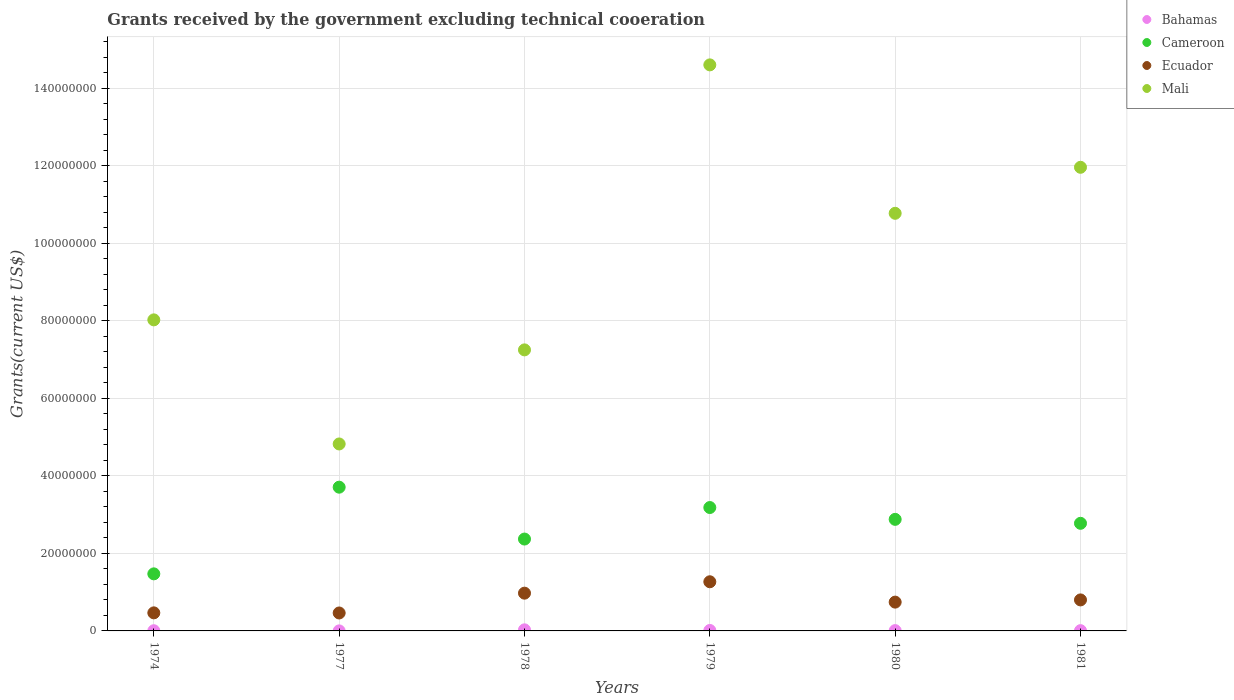How many different coloured dotlines are there?
Offer a terse response. 4. What is the total grants received by the government in Bahamas in 1979?
Provide a succinct answer. 1.20e+05. Across all years, what is the maximum total grants received by the government in Bahamas?
Provide a succinct answer. 2.80e+05. Across all years, what is the minimum total grants received by the government in Cameroon?
Provide a succinct answer. 1.47e+07. In which year was the total grants received by the government in Bahamas maximum?
Offer a terse response. 1978. In which year was the total grants received by the government in Cameroon minimum?
Your answer should be very brief. 1974. What is the total total grants received by the government in Cameroon in the graph?
Provide a succinct answer. 1.64e+08. What is the difference between the total grants received by the government in Bahamas in 1974 and that in 1981?
Provide a short and direct response. -2.00e+04. What is the difference between the total grants received by the government in Ecuador in 1980 and the total grants received by the government in Mali in 1977?
Your response must be concise. -4.08e+07. What is the average total grants received by the government in Mali per year?
Keep it short and to the point. 9.57e+07. In the year 1980, what is the difference between the total grants received by the government in Bahamas and total grants received by the government in Ecuador?
Give a very brief answer. -7.35e+06. What is the ratio of the total grants received by the government in Mali in 1977 to that in 1978?
Give a very brief answer. 0.67. Is the total grants received by the government in Ecuador in 1974 less than that in 1977?
Your response must be concise. No. What is the difference between the highest and the second highest total grants received by the government in Cameroon?
Your answer should be compact. 5.25e+06. What is the difference between the highest and the lowest total grants received by the government in Bahamas?
Your answer should be compact. 2.70e+05. In how many years, is the total grants received by the government in Cameroon greater than the average total grants received by the government in Cameroon taken over all years?
Keep it short and to the point. 4. Is the sum of the total grants received by the government in Ecuador in 1974 and 1977 greater than the maximum total grants received by the government in Mali across all years?
Give a very brief answer. No. Is it the case that in every year, the sum of the total grants received by the government in Cameroon and total grants received by the government in Mali  is greater than the total grants received by the government in Ecuador?
Keep it short and to the point. Yes. Is the total grants received by the government in Bahamas strictly less than the total grants received by the government in Ecuador over the years?
Your answer should be very brief. Yes. How many dotlines are there?
Offer a very short reply. 4. What is the difference between two consecutive major ticks on the Y-axis?
Your response must be concise. 2.00e+07. Does the graph contain any zero values?
Give a very brief answer. No. Where does the legend appear in the graph?
Ensure brevity in your answer.  Top right. How many legend labels are there?
Ensure brevity in your answer.  4. What is the title of the graph?
Provide a short and direct response. Grants received by the government excluding technical cooeration. Does "Caribbean small states" appear as one of the legend labels in the graph?
Offer a very short reply. No. What is the label or title of the X-axis?
Your answer should be very brief. Years. What is the label or title of the Y-axis?
Your answer should be compact. Grants(current US$). What is the Grants(current US$) of Cameroon in 1974?
Ensure brevity in your answer.  1.47e+07. What is the Grants(current US$) in Ecuador in 1974?
Make the answer very short. 4.66e+06. What is the Grants(current US$) in Mali in 1974?
Your answer should be very brief. 8.02e+07. What is the Grants(current US$) in Bahamas in 1977?
Your response must be concise. 10000. What is the Grants(current US$) of Cameroon in 1977?
Provide a short and direct response. 3.71e+07. What is the Grants(current US$) in Ecuador in 1977?
Offer a terse response. 4.63e+06. What is the Grants(current US$) in Mali in 1977?
Offer a very short reply. 4.82e+07. What is the Grants(current US$) in Cameroon in 1978?
Give a very brief answer. 2.37e+07. What is the Grants(current US$) in Ecuador in 1978?
Keep it short and to the point. 9.74e+06. What is the Grants(current US$) of Mali in 1978?
Provide a succinct answer. 7.25e+07. What is the Grants(current US$) in Bahamas in 1979?
Your response must be concise. 1.20e+05. What is the Grants(current US$) of Cameroon in 1979?
Ensure brevity in your answer.  3.18e+07. What is the Grants(current US$) in Ecuador in 1979?
Ensure brevity in your answer.  1.27e+07. What is the Grants(current US$) in Mali in 1979?
Keep it short and to the point. 1.46e+08. What is the Grants(current US$) of Bahamas in 1980?
Your answer should be compact. 8.00e+04. What is the Grants(current US$) in Cameroon in 1980?
Make the answer very short. 2.88e+07. What is the Grants(current US$) of Ecuador in 1980?
Your answer should be very brief. 7.43e+06. What is the Grants(current US$) in Mali in 1980?
Keep it short and to the point. 1.08e+08. What is the Grants(current US$) in Bahamas in 1981?
Your answer should be compact. 7.00e+04. What is the Grants(current US$) of Cameroon in 1981?
Keep it short and to the point. 2.78e+07. What is the Grants(current US$) in Mali in 1981?
Ensure brevity in your answer.  1.20e+08. Across all years, what is the maximum Grants(current US$) in Cameroon?
Ensure brevity in your answer.  3.71e+07. Across all years, what is the maximum Grants(current US$) in Ecuador?
Make the answer very short. 1.27e+07. Across all years, what is the maximum Grants(current US$) in Mali?
Make the answer very short. 1.46e+08. Across all years, what is the minimum Grants(current US$) in Bahamas?
Your answer should be very brief. 10000. Across all years, what is the minimum Grants(current US$) of Cameroon?
Offer a terse response. 1.47e+07. Across all years, what is the minimum Grants(current US$) in Ecuador?
Make the answer very short. 4.63e+06. Across all years, what is the minimum Grants(current US$) of Mali?
Give a very brief answer. 4.82e+07. What is the total Grants(current US$) in Cameroon in the graph?
Provide a short and direct response. 1.64e+08. What is the total Grants(current US$) of Ecuador in the graph?
Your response must be concise. 4.71e+07. What is the total Grants(current US$) of Mali in the graph?
Provide a succinct answer. 5.74e+08. What is the difference between the Grants(current US$) in Cameroon in 1974 and that in 1977?
Offer a very short reply. -2.24e+07. What is the difference between the Grants(current US$) of Mali in 1974 and that in 1977?
Provide a short and direct response. 3.20e+07. What is the difference between the Grants(current US$) in Cameroon in 1974 and that in 1978?
Provide a short and direct response. -8.98e+06. What is the difference between the Grants(current US$) of Ecuador in 1974 and that in 1978?
Make the answer very short. -5.08e+06. What is the difference between the Grants(current US$) of Mali in 1974 and that in 1978?
Offer a very short reply. 7.74e+06. What is the difference between the Grants(current US$) of Cameroon in 1974 and that in 1979?
Make the answer very short. -1.71e+07. What is the difference between the Grants(current US$) in Ecuador in 1974 and that in 1979?
Your answer should be very brief. -8.02e+06. What is the difference between the Grants(current US$) in Mali in 1974 and that in 1979?
Provide a short and direct response. -6.58e+07. What is the difference between the Grants(current US$) in Bahamas in 1974 and that in 1980?
Make the answer very short. -3.00e+04. What is the difference between the Grants(current US$) of Cameroon in 1974 and that in 1980?
Offer a terse response. -1.41e+07. What is the difference between the Grants(current US$) of Ecuador in 1974 and that in 1980?
Ensure brevity in your answer.  -2.77e+06. What is the difference between the Grants(current US$) in Mali in 1974 and that in 1980?
Your response must be concise. -2.75e+07. What is the difference between the Grants(current US$) in Bahamas in 1974 and that in 1981?
Offer a very short reply. -2.00e+04. What is the difference between the Grants(current US$) in Cameroon in 1974 and that in 1981?
Offer a very short reply. -1.30e+07. What is the difference between the Grants(current US$) in Ecuador in 1974 and that in 1981?
Offer a terse response. -3.34e+06. What is the difference between the Grants(current US$) in Mali in 1974 and that in 1981?
Offer a terse response. -3.94e+07. What is the difference between the Grants(current US$) of Bahamas in 1977 and that in 1978?
Give a very brief answer. -2.70e+05. What is the difference between the Grants(current US$) in Cameroon in 1977 and that in 1978?
Offer a very short reply. 1.34e+07. What is the difference between the Grants(current US$) of Ecuador in 1977 and that in 1978?
Make the answer very short. -5.11e+06. What is the difference between the Grants(current US$) of Mali in 1977 and that in 1978?
Give a very brief answer. -2.43e+07. What is the difference between the Grants(current US$) of Bahamas in 1977 and that in 1979?
Provide a succinct answer. -1.10e+05. What is the difference between the Grants(current US$) of Cameroon in 1977 and that in 1979?
Your answer should be very brief. 5.25e+06. What is the difference between the Grants(current US$) of Ecuador in 1977 and that in 1979?
Provide a short and direct response. -8.05e+06. What is the difference between the Grants(current US$) in Mali in 1977 and that in 1979?
Ensure brevity in your answer.  -9.78e+07. What is the difference between the Grants(current US$) in Cameroon in 1977 and that in 1980?
Your answer should be compact. 8.30e+06. What is the difference between the Grants(current US$) in Ecuador in 1977 and that in 1980?
Offer a terse response. -2.80e+06. What is the difference between the Grants(current US$) in Mali in 1977 and that in 1980?
Keep it short and to the point. -5.95e+07. What is the difference between the Grants(current US$) in Cameroon in 1977 and that in 1981?
Provide a succinct answer. 9.32e+06. What is the difference between the Grants(current US$) in Ecuador in 1977 and that in 1981?
Provide a short and direct response. -3.37e+06. What is the difference between the Grants(current US$) of Mali in 1977 and that in 1981?
Your response must be concise. -7.14e+07. What is the difference between the Grants(current US$) in Bahamas in 1978 and that in 1979?
Your response must be concise. 1.60e+05. What is the difference between the Grants(current US$) in Cameroon in 1978 and that in 1979?
Keep it short and to the point. -8.13e+06. What is the difference between the Grants(current US$) of Ecuador in 1978 and that in 1979?
Give a very brief answer. -2.94e+06. What is the difference between the Grants(current US$) in Mali in 1978 and that in 1979?
Provide a succinct answer. -7.35e+07. What is the difference between the Grants(current US$) of Bahamas in 1978 and that in 1980?
Offer a very short reply. 2.00e+05. What is the difference between the Grants(current US$) in Cameroon in 1978 and that in 1980?
Offer a very short reply. -5.08e+06. What is the difference between the Grants(current US$) in Ecuador in 1978 and that in 1980?
Make the answer very short. 2.31e+06. What is the difference between the Grants(current US$) of Mali in 1978 and that in 1980?
Offer a terse response. -3.52e+07. What is the difference between the Grants(current US$) of Bahamas in 1978 and that in 1981?
Your answer should be compact. 2.10e+05. What is the difference between the Grants(current US$) of Cameroon in 1978 and that in 1981?
Provide a succinct answer. -4.06e+06. What is the difference between the Grants(current US$) of Ecuador in 1978 and that in 1981?
Keep it short and to the point. 1.74e+06. What is the difference between the Grants(current US$) in Mali in 1978 and that in 1981?
Your answer should be compact. -4.71e+07. What is the difference between the Grants(current US$) in Bahamas in 1979 and that in 1980?
Your answer should be very brief. 4.00e+04. What is the difference between the Grants(current US$) in Cameroon in 1979 and that in 1980?
Your answer should be compact. 3.05e+06. What is the difference between the Grants(current US$) of Ecuador in 1979 and that in 1980?
Your answer should be very brief. 5.25e+06. What is the difference between the Grants(current US$) in Mali in 1979 and that in 1980?
Ensure brevity in your answer.  3.83e+07. What is the difference between the Grants(current US$) in Bahamas in 1979 and that in 1981?
Offer a very short reply. 5.00e+04. What is the difference between the Grants(current US$) of Cameroon in 1979 and that in 1981?
Keep it short and to the point. 4.07e+06. What is the difference between the Grants(current US$) in Ecuador in 1979 and that in 1981?
Keep it short and to the point. 4.68e+06. What is the difference between the Grants(current US$) in Mali in 1979 and that in 1981?
Give a very brief answer. 2.64e+07. What is the difference between the Grants(current US$) of Bahamas in 1980 and that in 1981?
Provide a succinct answer. 10000. What is the difference between the Grants(current US$) of Cameroon in 1980 and that in 1981?
Offer a very short reply. 1.02e+06. What is the difference between the Grants(current US$) of Ecuador in 1980 and that in 1981?
Your response must be concise. -5.70e+05. What is the difference between the Grants(current US$) in Mali in 1980 and that in 1981?
Your response must be concise. -1.19e+07. What is the difference between the Grants(current US$) in Bahamas in 1974 and the Grants(current US$) in Cameroon in 1977?
Give a very brief answer. -3.70e+07. What is the difference between the Grants(current US$) in Bahamas in 1974 and the Grants(current US$) in Ecuador in 1977?
Ensure brevity in your answer.  -4.58e+06. What is the difference between the Grants(current US$) of Bahamas in 1974 and the Grants(current US$) of Mali in 1977?
Your answer should be very brief. -4.82e+07. What is the difference between the Grants(current US$) of Cameroon in 1974 and the Grants(current US$) of Ecuador in 1977?
Your answer should be compact. 1.01e+07. What is the difference between the Grants(current US$) in Cameroon in 1974 and the Grants(current US$) in Mali in 1977?
Your answer should be compact. -3.35e+07. What is the difference between the Grants(current US$) in Ecuador in 1974 and the Grants(current US$) in Mali in 1977?
Your answer should be very brief. -4.36e+07. What is the difference between the Grants(current US$) of Bahamas in 1974 and the Grants(current US$) of Cameroon in 1978?
Provide a succinct answer. -2.36e+07. What is the difference between the Grants(current US$) in Bahamas in 1974 and the Grants(current US$) in Ecuador in 1978?
Your answer should be very brief. -9.69e+06. What is the difference between the Grants(current US$) in Bahamas in 1974 and the Grants(current US$) in Mali in 1978?
Keep it short and to the point. -7.24e+07. What is the difference between the Grants(current US$) in Cameroon in 1974 and the Grants(current US$) in Ecuador in 1978?
Your response must be concise. 4.98e+06. What is the difference between the Grants(current US$) of Cameroon in 1974 and the Grants(current US$) of Mali in 1978?
Offer a terse response. -5.78e+07. What is the difference between the Grants(current US$) in Ecuador in 1974 and the Grants(current US$) in Mali in 1978?
Your answer should be very brief. -6.78e+07. What is the difference between the Grants(current US$) in Bahamas in 1974 and the Grants(current US$) in Cameroon in 1979?
Keep it short and to the point. -3.18e+07. What is the difference between the Grants(current US$) in Bahamas in 1974 and the Grants(current US$) in Ecuador in 1979?
Keep it short and to the point. -1.26e+07. What is the difference between the Grants(current US$) in Bahamas in 1974 and the Grants(current US$) in Mali in 1979?
Provide a succinct answer. -1.46e+08. What is the difference between the Grants(current US$) in Cameroon in 1974 and the Grants(current US$) in Ecuador in 1979?
Provide a succinct answer. 2.04e+06. What is the difference between the Grants(current US$) of Cameroon in 1974 and the Grants(current US$) of Mali in 1979?
Keep it short and to the point. -1.31e+08. What is the difference between the Grants(current US$) in Ecuador in 1974 and the Grants(current US$) in Mali in 1979?
Give a very brief answer. -1.41e+08. What is the difference between the Grants(current US$) in Bahamas in 1974 and the Grants(current US$) in Cameroon in 1980?
Offer a very short reply. -2.87e+07. What is the difference between the Grants(current US$) in Bahamas in 1974 and the Grants(current US$) in Ecuador in 1980?
Keep it short and to the point. -7.38e+06. What is the difference between the Grants(current US$) in Bahamas in 1974 and the Grants(current US$) in Mali in 1980?
Ensure brevity in your answer.  -1.08e+08. What is the difference between the Grants(current US$) of Cameroon in 1974 and the Grants(current US$) of Ecuador in 1980?
Provide a succinct answer. 7.29e+06. What is the difference between the Grants(current US$) in Cameroon in 1974 and the Grants(current US$) in Mali in 1980?
Your response must be concise. -9.30e+07. What is the difference between the Grants(current US$) in Ecuador in 1974 and the Grants(current US$) in Mali in 1980?
Offer a very short reply. -1.03e+08. What is the difference between the Grants(current US$) in Bahamas in 1974 and the Grants(current US$) in Cameroon in 1981?
Keep it short and to the point. -2.77e+07. What is the difference between the Grants(current US$) in Bahamas in 1974 and the Grants(current US$) in Ecuador in 1981?
Your response must be concise. -7.95e+06. What is the difference between the Grants(current US$) of Bahamas in 1974 and the Grants(current US$) of Mali in 1981?
Offer a terse response. -1.20e+08. What is the difference between the Grants(current US$) of Cameroon in 1974 and the Grants(current US$) of Ecuador in 1981?
Provide a short and direct response. 6.72e+06. What is the difference between the Grants(current US$) of Cameroon in 1974 and the Grants(current US$) of Mali in 1981?
Provide a short and direct response. -1.05e+08. What is the difference between the Grants(current US$) in Ecuador in 1974 and the Grants(current US$) in Mali in 1981?
Offer a terse response. -1.15e+08. What is the difference between the Grants(current US$) in Bahamas in 1977 and the Grants(current US$) in Cameroon in 1978?
Your answer should be compact. -2.37e+07. What is the difference between the Grants(current US$) of Bahamas in 1977 and the Grants(current US$) of Ecuador in 1978?
Your response must be concise. -9.73e+06. What is the difference between the Grants(current US$) of Bahamas in 1977 and the Grants(current US$) of Mali in 1978?
Give a very brief answer. -7.25e+07. What is the difference between the Grants(current US$) of Cameroon in 1977 and the Grants(current US$) of Ecuador in 1978?
Make the answer very short. 2.73e+07. What is the difference between the Grants(current US$) in Cameroon in 1977 and the Grants(current US$) in Mali in 1978?
Your answer should be very brief. -3.54e+07. What is the difference between the Grants(current US$) in Ecuador in 1977 and the Grants(current US$) in Mali in 1978?
Give a very brief answer. -6.79e+07. What is the difference between the Grants(current US$) in Bahamas in 1977 and the Grants(current US$) in Cameroon in 1979?
Offer a very short reply. -3.18e+07. What is the difference between the Grants(current US$) in Bahamas in 1977 and the Grants(current US$) in Ecuador in 1979?
Your answer should be compact. -1.27e+07. What is the difference between the Grants(current US$) of Bahamas in 1977 and the Grants(current US$) of Mali in 1979?
Provide a succinct answer. -1.46e+08. What is the difference between the Grants(current US$) in Cameroon in 1977 and the Grants(current US$) in Ecuador in 1979?
Provide a succinct answer. 2.44e+07. What is the difference between the Grants(current US$) in Cameroon in 1977 and the Grants(current US$) in Mali in 1979?
Make the answer very short. -1.09e+08. What is the difference between the Grants(current US$) of Ecuador in 1977 and the Grants(current US$) of Mali in 1979?
Provide a succinct answer. -1.41e+08. What is the difference between the Grants(current US$) in Bahamas in 1977 and the Grants(current US$) in Cameroon in 1980?
Ensure brevity in your answer.  -2.88e+07. What is the difference between the Grants(current US$) of Bahamas in 1977 and the Grants(current US$) of Ecuador in 1980?
Provide a short and direct response. -7.42e+06. What is the difference between the Grants(current US$) of Bahamas in 1977 and the Grants(current US$) of Mali in 1980?
Your response must be concise. -1.08e+08. What is the difference between the Grants(current US$) of Cameroon in 1977 and the Grants(current US$) of Ecuador in 1980?
Offer a terse response. 2.96e+07. What is the difference between the Grants(current US$) of Cameroon in 1977 and the Grants(current US$) of Mali in 1980?
Make the answer very short. -7.06e+07. What is the difference between the Grants(current US$) of Ecuador in 1977 and the Grants(current US$) of Mali in 1980?
Your answer should be very brief. -1.03e+08. What is the difference between the Grants(current US$) in Bahamas in 1977 and the Grants(current US$) in Cameroon in 1981?
Your response must be concise. -2.78e+07. What is the difference between the Grants(current US$) of Bahamas in 1977 and the Grants(current US$) of Ecuador in 1981?
Give a very brief answer. -7.99e+06. What is the difference between the Grants(current US$) of Bahamas in 1977 and the Grants(current US$) of Mali in 1981?
Your response must be concise. -1.20e+08. What is the difference between the Grants(current US$) of Cameroon in 1977 and the Grants(current US$) of Ecuador in 1981?
Offer a terse response. 2.91e+07. What is the difference between the Grants(current US$) in Cameroon in 1977 and the Grants(current US$) in Mali in 1981?
Make the answer very short. -8.25e+07. What is the difference between the Grants(current US$) of Ecuador in 1977 and the Grants(current US$) of Mali in 1981?
Your answer should be very brief. -1.15e+08. What is the difference between the Grants(current US$) of Bahamas in 1978 and the Grants(current US$) of Cameroon in 1979?
Ensure brevity in your answer.  -3.16e+07. What is the difference between the Grants(current US$) of Bahamas in 1978 and the Grants(current US$) of Ecuador in 1979?
Provide a short and direct response. -1.24e+07. What is the difference between the Grants(current US$) of Bahamas in 1978 and the Grants(current US$) of Mali in 1979?
Give a very brief answer. -1.46e+08. What is the difference between the Grants(current US$) of Cameroon in 1978 and the Grants(current US$) of Ecuador in 1979?
Your answer should be compact. 1.10e+07. What is the difference between the Grants(current US$) in Cameroon in 1978 and the Grants(current US$) in Mali in 1979?
Your answer should be very brief. -1.22e+08. What is the difference between the Grants(current US$) in Ecuador in 1978 and the Grants(current US$) in Mali in 1979?
Your answer should be very brief. -1.36e+08. What is the difference between the Grants(current US$) of Bahamas in 1978 and the Grants(current US$) of Cameroon in 1980?
Offer a terse response. -2.85e+07. What is the difference between the Grants(current US$) of Bahamas in 1978 and the Grants(current US$) of Ecuador in 1980?
Ensure brevity in your answer.  -7.15e+06. What is the difference between the Grants(current US$) in Bahamas in 1978 and the Grants(current US$) in Mali in 1980?
Make the answer very short. -1.07e+08. What is the difference between the Grants(current US$) of Cameroon in 1978 and the Grants(current US$) of Ecuador in 1980?
Make the answer very short. 1.63e+07. What is the difference between the Grants(current US$) of Cameroon in 1978 and the Grants(current US$) of Mali in 1980?
Provide a short and direct response. -8.40e+07. What is the difference between the Grants(current US$) of Ecuador in 1978 and the Grants(current US$) of Mali in 1980?
Provide a short and direct response. -9.80e+07. What is the difference between the Grants(current US$) of Bahamas in 1978 and the Grants(current US$) of Cameroon in 1981?
Offer a terse response. -2.75e+07. What is the difference between the Grants(current US$) of Bahamas in 1978 and the Grants(current US$) of Ecuador in 1981?
Give a very brief answer. -7.72e+06. What is the difference between the Grants(current US$) in Bahamas in 1978 and the Grants(current US$) in Mali in 1981?
Offer a terse response. -1.19e+08. What is the difference between the Grants(current US$) of Cameroon in 1978 and the Grants(current US$) of Ecuador in 1981?
Offer a terse response. 1.57e+07. What is the difference between the Grants(current US$) in Cameroon in 1978 and the Grants(current US$) in Mali in 1981?
Give a very brief answer. -9.59e+07. What is the difference between the Grants(current US$) in Ecuador in 1978 and the Grants(current US$) in Mali in 1981?
Your response must be concise. -1.10e+08. What is the difference between the Grants(current US$) of Bahamas in 1979 and the Grants(current US$) of Cameroon in 1980?
Offer a terse response. -2.87e+07. What is the difference between the Grants(current US$) of Bahamas in 1979 and the Grants(current US$) of Ecuador in 1980?
Your answer should be very brief. -7.31e+06. What is the difference between the Grants(current US$) of Bahamas in 1979 and the Grants(current US$) of Mali in 1980?
Ensure brevity in your answer.  -1.08e+08. What is the difference between the Grants(current US$) in Cameroon in 1979 and the Grants(current US$) in Ecuador in 1980?
Keep it short and to the point. 2.44e+07. What is the difference between the Grants(current US$) in Cameroon in 1979 and the Grants(current US$) in Mali in 1980?
Provide a short and direct response. -7.59e+07. What is the difference between the Grants(current US$) in Ecuador in 1979 and the Grants(current US$) in Mali in 1980?
Make the answer very short. -9.50e+07. What is the difference between the Grants(current US$) in Bahamas in 1979 and the Grants(current US$) in Cameroon in 1981?
Ensure brevity in your answer.  -2.76e+07. What is the difference between the Grants(current US$) in Bahamas in 1979 and the Grants(current US$) in Ecuador in 1981?
Provide a succinct answer. -7.88e+06. What is the difference between the Grants(current US$) of Bahamas in 1979 and the Grants(current US$) of Mali in 1981?
Your answer should be compact. -1.19e+08. What is the difference between the Grants(current US$) of Cameroon in 1979 and the Grants(current US$) of Ecuador in 1981?
Your response must be concise. 2.38e+07. What is the difference between the Grants(current US$) of Cameroon in 1979 and the Grants(current US$) of Mali in 1981?
Your answer should be very brief. -8.78e+07. What is the difference between the Grants(current US$) in Ecuador in 1979 and the Grants(current US$) in Mali in 1981?
Your response must be concise. -1.07e+08. What is the difference between the Grants(current US$) in Bahamas in 1980 and the Grants(current US$) in Cameroon in 1981?
Ensure brevity in your answer.  -2.77e+07. What is the difference between the Grants(current US$) of Bahamas in 1980 and the Grants(current US$) of Ecuador in 1981?
Offer a terse response. -7.92e+06. What is the difference between the Grants(current US$) in Bahamas in 1980 and the Grants(current US$) in Mali in 1981?
Give a very brief answer. -1.20e+08. What is the difference between the Grants(current US$) of Cameroon in 1980 and the Grants(current US$) of Ecuador in 1981?
Give a very brief answer. 2.08e+07. What is the difference between the Grants(current US$) of Cameroon in 1980 and the Grants(current US$) of Mali in 1981?
Ensure brevity in your answer.  -9.08e+07. What is the difference between the Grants(current US$) of Ecuador in 1980 and the Grants(current US$) of Mali in 1981?
Your response must be concise. -1.12e+08. What is the average Grants(current US$) of Bahamas per year?
Make the answer very short. 1.02e+05. What is the average Grants(current US$) of Cameroon per year?
Offer a very short reply. 2.73e+07. What is the average Grants(current US$) in Ecuador per year?
Provide a succinct answer. 7.86e+06. What is the average Grants(current US$) of Mali per year?
Ensure brevity in your answer.  9.57e+07. In the year 1974, what is the difference between the Grants(current US$) of Bahamas and Grants(current US$) of Cameroon?
Provide a succinct answer. -1.47e+07. In the year 1974, what is the difference between the Grants(current US$) of Bahamas and Grants(current US$) of Ecuador?
Your answer should be compact. -4.61e+06. In the year 1974, what is the difference between the Grants(current US$) of Bahamas and Grants(current US$) of Mali?
Ensure brevity in your answer.  -8.02e+07. In the year 1974, what is the difference between the Grants(current US$) of Cameroon and Grants(current US$) of Ecuador?
Offer a very short reply. 1.01e+07. In the year 1974, what is the difference between the Grants(current US$) in Cameroon and Grants(current US$) in Mali?
Offer a terse response. -6.55e+07. In the year 1974, what is the difference between the Grants(current US$) of Ecuador and Grants(current US$) of Mali?
Your response must be concise. -7.56e+07. In the year 1977, what is the difference between the Grants(current US$) in Bahamas and Grants(current US$) in Cameroon?
Your answer should be very brief. -3.71e+07. In the year 1977, what is the difference between the Grants(current US$) in Bahamas and Grants(current US$) in Ecuador?
Your answer should be very brief. -4.62e+06. In the year 1977, what is the difference between the Grants(current US$) of Bahamas and Grants(current US$) of Mali?
Your answer should be compact. -4.82e+07. In the year 1977, what is the difference between the Grants(current US$) of Cameroon and Grants(current US$) of Ecuador?
Provide a short and direct response. 3.24e+07. In the year 1977, what is the difference between the Grants(current US$) in Cameroon and Grants(current US$) in Mali?
Your answer should be compact. -1.12e+07. In the year 1977, what is the difference between the Grants(current US$) of Ecuador and Grants(current US$) of Mali?
Keep it short and to the point. -4.36e+07. In the year 1978, what is the difference between the Grants(current US$) of Bahamas and Grants(current US$) of Cameroon?
Your response must be concise. -2.34e+07. In the year 1978, what is the difference between the Grants(current US$) of Bahamas and Grants(current US$) of Ecuador?
Your answer should be very brief. -9.46e+06. In the year 1978, what is the difference between the Grants(current US$) of Bahamas and Grants(current US$) of Mali?
Offer a terse response. -7.22e+07. In the year 1978, what is the difference between the Grants(current US$) of Cameroon and Grants(current US$) of Ecuador?
Offer a terse response. 1.40e+07. In the year 1978, what is the difference between the Grants(current US$) in Cameroon and Grants(current US$) in Mali?
Your answer should be very brief. -4.88e+07. In the year 1978, what is the difference between the Grants(current US$) in Ecuador and Grants(current US$) in Mali?
Provide a succinct answer. -6.28e+07. In the year 1979, what is the difference between the Grants(current US$) in Bahamas and Grants(current US$) in Cameroon?
Give a very brief answer. -3.17e+07. In the year 1979, what is the difference between the Grants(current US$) in Bahamas and Grants(current US$) in Ecuador?
Your answer should be very brief. -1.26e+07. In the year 1979, what is the difference between the Grants(current US$) of Bahamas and Grants(current US$) of Mali?
Offer a very short reply. -1.46e+08. In the year 1979, what is the difference between the Grants(current US$) of Cameroon and Grants(current US$) of Ecuador?
Your answer should be compact. 1.92e+07. In the year 1979, what is the difference between the Grants(current US$) in Cameroon and Grants(current US$) in Mali?
Your answer should be compact. -1.14e+08. In the year 1979, what is the difference between the Grants(current US$) in Ecuador and Grants(current US$) in Mali?
Provide a short and direct response. -1.33e+08. In the year 1980, what is the difference between the Grants(current US$) of Bahamas and Grants(current US$) of Cameroon?
Your answer should be very brief. -2.87e+07. In the year 1980, what is the difference between the Grants(current US$) in Bahamas and Grants(current US$) in Ecuador?
Provide a short and direct response. -7.35e+06. In the year 1980, what is the difference between the Grants(current US$) in Bahamas and Grants(current US$) in Mali?
Make the answer very short. -1.08e+08. In the year 1980, what is the difference between the Grants(current US$) of Cameroon and Grants(current US$) of Ecuador?
Keep it short and to the point. 2.14e+07. In the year 1980, what is the difference between the Grants(current US$) in Cameroon and Grants(current US$) in Mali?
Offer a terse response. -7.90e+07. In the year 1980, what is the difference between the Grants(current US$) of Ecuador and Grants(current US$) of Mali?
Your answer should be very brief. -1.00e+08. In the year 1981, what is the difference between the Grants(current US$) in Bahamas and Grants(current US$) in Cameroon?
Offer a terse response. -2.77e+07. In the year 1981, what is the difference between the Grants(current US$) in Bahamas and Grants(current US$) in Ecuador?
Ensure brevity in your answer.  -7.93e+06. In the year 1981, what is the difference between the Grants(current US$) in Bahamas and Grants(current US$) in Mali?
Provide a succinct answer. -1.20e+08. In the year 1981, what is the difference between the Grants(current US$) in Cameroon and Grants(current US$) in Ecuador?
Give a very brief answer. 1.98e+07. In the year 1981, what is the difference between the Grants(current US$) in Cameroon and Grants(current US$) in Mali?
Keep it short and to the point. -9.18e+07. In the year 1981, what is the difference between the Grants(current US$) of Ecuador and Grants(current US$) of Mali?
Give a very brief answer. -1.12e+08. What is the ratio of the Grants(current US$) of Cameroon in 1974 to that in 1977?
Offer a very short reply. 0.4. What is the ratio of the Grants(current US$) of Mali in 1974 to that in 1977?
Ensure brevity in your answer.  1.66. What is the ratio of the Grants(current US$) in Bahamas in 1974 to that in 1978?
Give a very brief answer. 0.18. What is the ratio of the Grants(current US$) of Cameroon in 1974 to that in 1978?
Provide a succinct answer. 0.62. What is the ratio of the Grants(current US$) of Ecuador in 1974 to that in 1978?
Your response must be concise. 0.48. What is the ratio of the Grants(current US$) in Mali in 1974 to that in 1978?
Ensure brevity in your answer.  1.11. What is the ratio of the Grants(current US$) in Bahamas in 1974 to that in 1979?
Ensure brevity in your answer.  0.42. What is the ratio of the Grants(current US$) of Cameroon in 1974 to that in 1979?
Your answer should be very brief. 0.46. What is the ratio of the Grants(current US$) of Ecuador in 1974 to that in 1979?
Give a very brief answer. 0.37. What is the ratio of the Grants(current US$) in Mali in 1974 to that in 1979?
Your answer should be very brief. 0.55. What is the ratio of the Grants(current US$) in Bahamas in 1974 to that in 1980?
Your response must be concise. 0.62. What is the ratio of the Grants(current US$) in Cameroon in 1974 to that in 1980?
Your answer should be compact. 0.51. What is the ratio of the Grants(current US$) of Ecuador in 1974 to that in 1980?
Offer a terse response. 0.63. What is the ratio of the Grants(current US$) of Mali in 1974 to that in 1980?
Give a very brief answer. 0.74. What is the ratio of the Grants(current US$) of Bahamas in 1974 to that in 1981?
Your answer should be very brief. 0.71. What is the ratio of the Grants(current US$) in Cameroon in 1974 to that in 1981?
Provide a short and direct response. 0.53. What is the ratio of the Grants(current US$) in Ecuador in 1974 to that in 1981?
Your response must be concise. 0.58. What is the ratio of the Grants(current US$) in Mali in 1974 to that in 1981?
Provide a succinct answer. 0.67. What is the ratio of the Grants(current US$) of Bahamas in 1977 to that in 1978?
Your answer should be compact. 0.04. What is the ratio of the Grants(current US$) in Cameroon in 1977 to that in 1978?
Offer a terse response. 1.56. What is the ratio of the Grants(current US$) of Ecuador in 1977 to that in 1978?
Provide a short and direct response. 0.48. What is the ratio of the Grants(current US$) in Mali in 1977 to that in 1978?
Ensure brevity in your answer.  0.67. What is the ratio of the Grants(current US$) of Bahamas in 1977 to that in 1979?
Provide a short and direct response. 0.08. What is the ratio of the Grants(current US$) in Cameroon in 1977 to that in 1979?
Provide a succinct answer. 1.16. What is the ratio of the Grants(current US$) in Ecuador in 1977 to that in 1979?
Ensure brevity in your answer.  0.37. What is the ratio of the Grants(current US$) of Mali in 1977 to that in 1979?
Provide a short and direct response. 0.33. What is the ratio of the Grants(current US$) of Bahamas in 1977 to that in 1980?
Your response must be concise. 0.12. What is the ratio of the Grants(current US$) of Cameroon in 1977 to that in 1980?
Give a very brief answer. 1.29. What is the ratio of the Grants(current US$) of Ecuador in 1977 to that in 1980?
Offer a terse response. 0.62. What is the ratio of the Grants(current US$) of Mali in 1977 to that in 1980?
Keep it short and to the point. 0.45. What is the ratio of the Grants(current US$) of Bahamas in 1977 to that in 1981?
Give a very brief answer. 0.14. What is the ratio of the Grants(current US$) in Cameroon in 1977 to that in 1981?
Make the answer very short. 1.34. What is the ratio of the Grants(current US$) in Ecuador in 1977 to that in 1981?
Make the answer very short. 0.58. What is the ratio of the Grants(current US$) in Mali in 1977 to that in 1981?
Provide a short and direct response. 0.4. What is the ratio of the Grants(current US$) of Bahamas in 1978 to that in 1979?
Offer a very short reply. 2.33. What is the ratio of the Grants(current US$) in Cameroon in 1978 to that in 1979?
Keep it short and to the point. 0.74. What is the ratio of the Grants(current US$) in Ecuador in 1978 to that in 1979?
Your response must be concise. 0.77. What is the ratio of the Grants(current US$) of Mali in 1978 to that in 1979?
Provide a short and direct response. 0.5. What is the ratio of the Grants(current US$) of Bahamas in 1978 to that in 1980?
Ensure brevity in your answer.  3.5. What is the ratio of the Grants(current US$) in Cameroon in 1978 to that in 1980?
Offer a terse response. 0.82. What is the ratio of the Grants(current US$) of Ecuador in 1978 to that in 1980?
Provide a succinct answer. 1.31. What is the ratio of the Grants(current US$) of Mali in 1978 to that in 1980?
Give a very brief answer. 0.67. What is the ratio of the Grants(current US$) of Bahamas in 1978 to that in 1981?
Your response must be concise. 4. What is the ratio of the Grants(current US$) in Cameroon in 1978 to that in 1981?
Make the answer very short. 0.85. What is the ratio of the Grants(current US$) in Ecuador in 1978 to that in 1981?
Your answer should be compact. 1.22. What is the ratio of the Grants(current US$) in Mali in 1978 to that in 1981?
Offer a terse response. 0.61. What is the ratio of the Grants(current US$) of Cameroon in 1979 to that in 1980?
Give a very brief answer. 1.11. What is the ratio of the Grants(current US$) of Ecuador in 1979 to that in 1980?
Offer a terse response. 1.71. What is the ratio of the Grants(current US$) in Mali in 1979 to that in 1980?
Offer a terse response. 1.36. What is the ratio of the Grants(current US$) in Bahamas in 1979 to that in 1981?
Your answer should be compact. 1.71. What is the ratio of the Grants(current US$) in Cameroon in 1979 to that in 1981?
Give a very brief answer. 1.15. What is the ratio of the Grants(current US$) in Ecuador in 1979 to that in 1981?
Your answer should be very brief. 1.58. What is the ratio of the Grants(current US$) of Mali in 1979 to that in 1981?
Offer a terse response. 1.22. What is the ratio of the Grants(current US$) in Cameroon in 1980 to that in 1981?
Your answer should be compact. 1.04. What is the ratio of the Grants(current US$) of Ecuador in 1980 to that in 1981?
Your answer should be compact. 0.93. What is the ratio of the Grants(current US$) in Mali in 1980 to that in 1981?
Offer a very short reply. 0.9. What is the difference between the highest and the second highest Grants(current US$) of Bahamas?
Your answer should be compact. 1.60e+05. What is the difference between the highest and the second highest Grants(current US$) in Cameroon?
Offer a terse response. 5.25e+06. What is the difference between the highest and the second highest Grants(current US$) in Ecuador?
Your answer should be very brief. 2.94e+06. What is the difference between the highest and the second highest Grants(current US$) of Mali?
Offer a terse response. 2.64e+07. What is the difference between the highest and the lowest Grants(current US$) of Bahamas?
Your answer should be compact. 2.70e+05. What is the difference between the highest and the lowest Grants(current US$) in Cameroon?
Keep it short and to the point. 2.24e+07. What is the difference between the highest and the lowest Grants(current US$) of Ecuador?
Keep it short and to the point. 8.05e+06. What is the difference between the highest and the lowest Grants(current US$) of Mali?
Your answer should be very brief. 9.78e+07. 